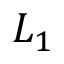<formula> <loc_0><loc_0><loc_500><loc_500>L _ { 1 }</formula> 